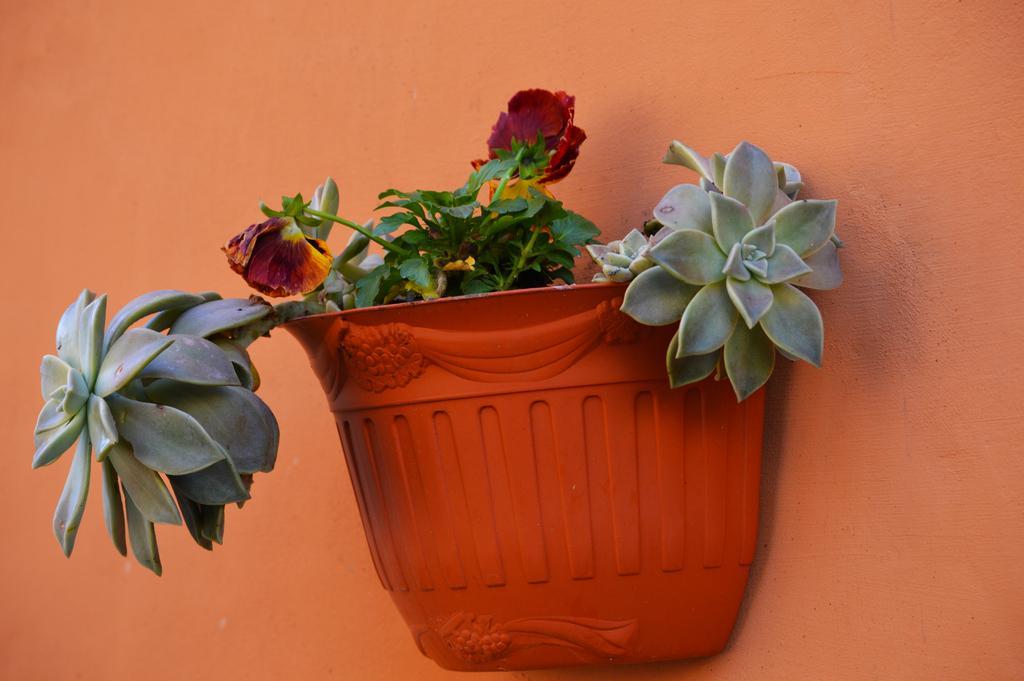Could you give a brief overview of what you see in this image? In this picture we can see a flower pot and a plant here, in the background there is a wall. 